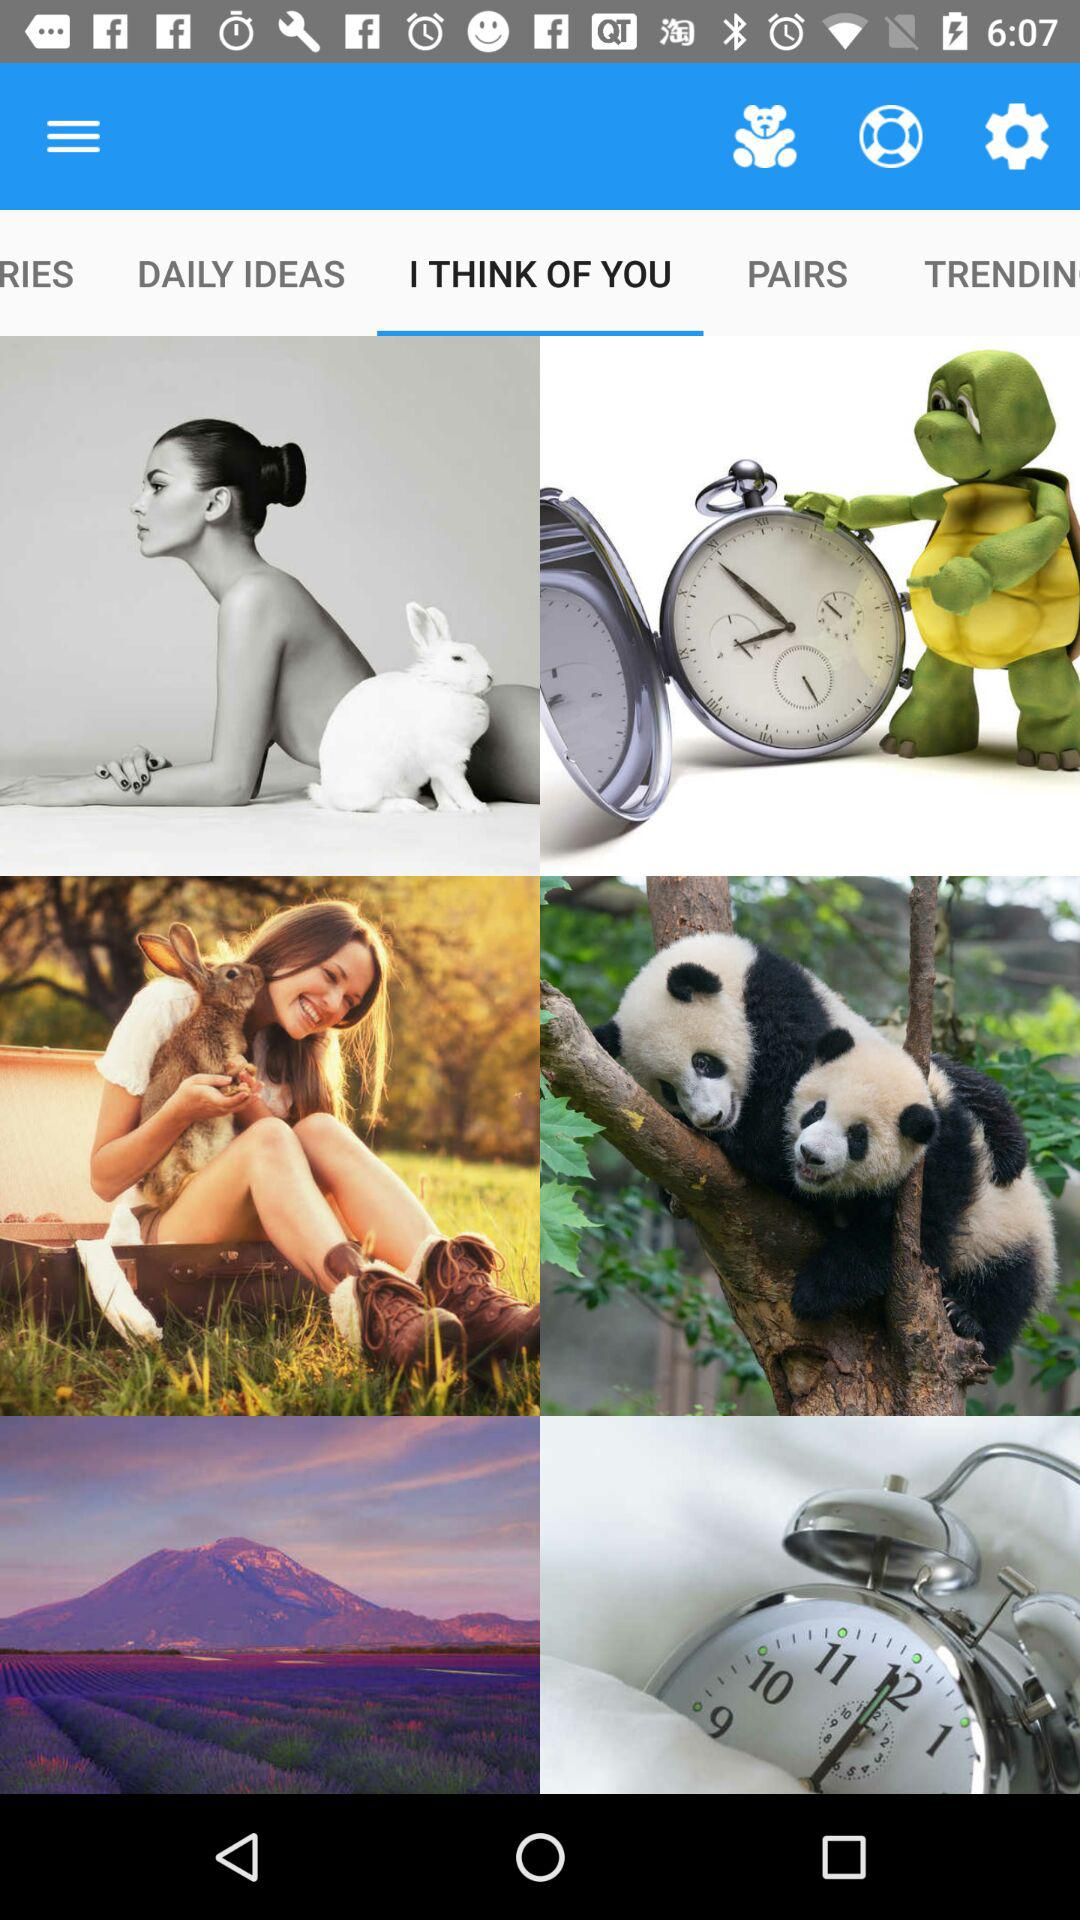Which tab is selected? The selected tab is "I THINK OF YOU". 